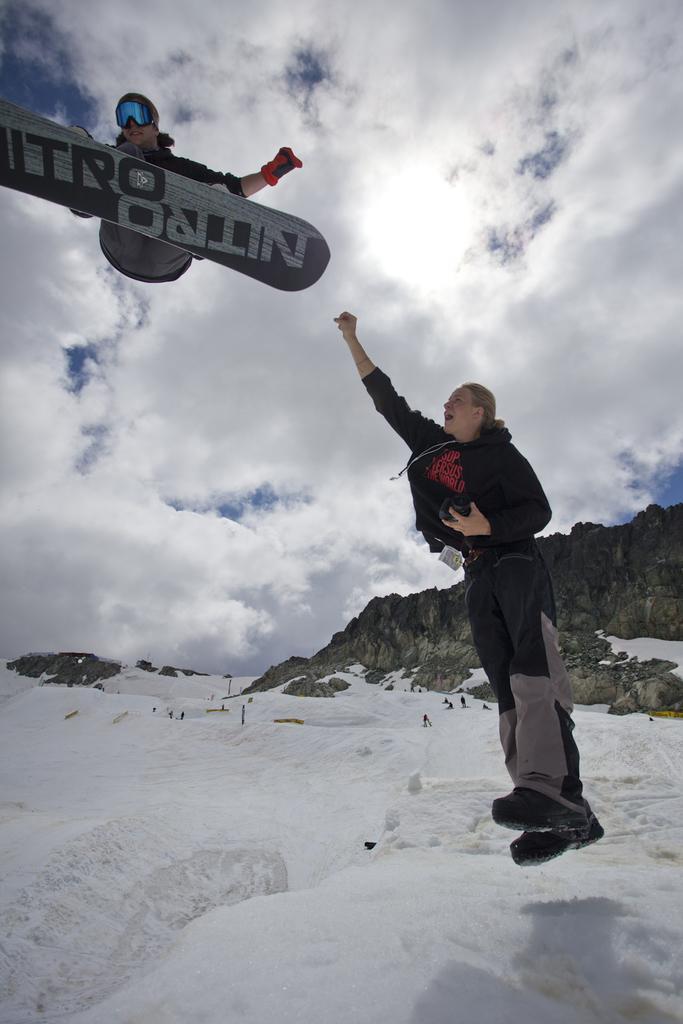Please provide a concise description of this image. On the left top I can see a person is skiing. In the foreground I can see a person on the mountain. In the background I can see mountains and the sky. This image is taken may be on the ice mountain during a day. 